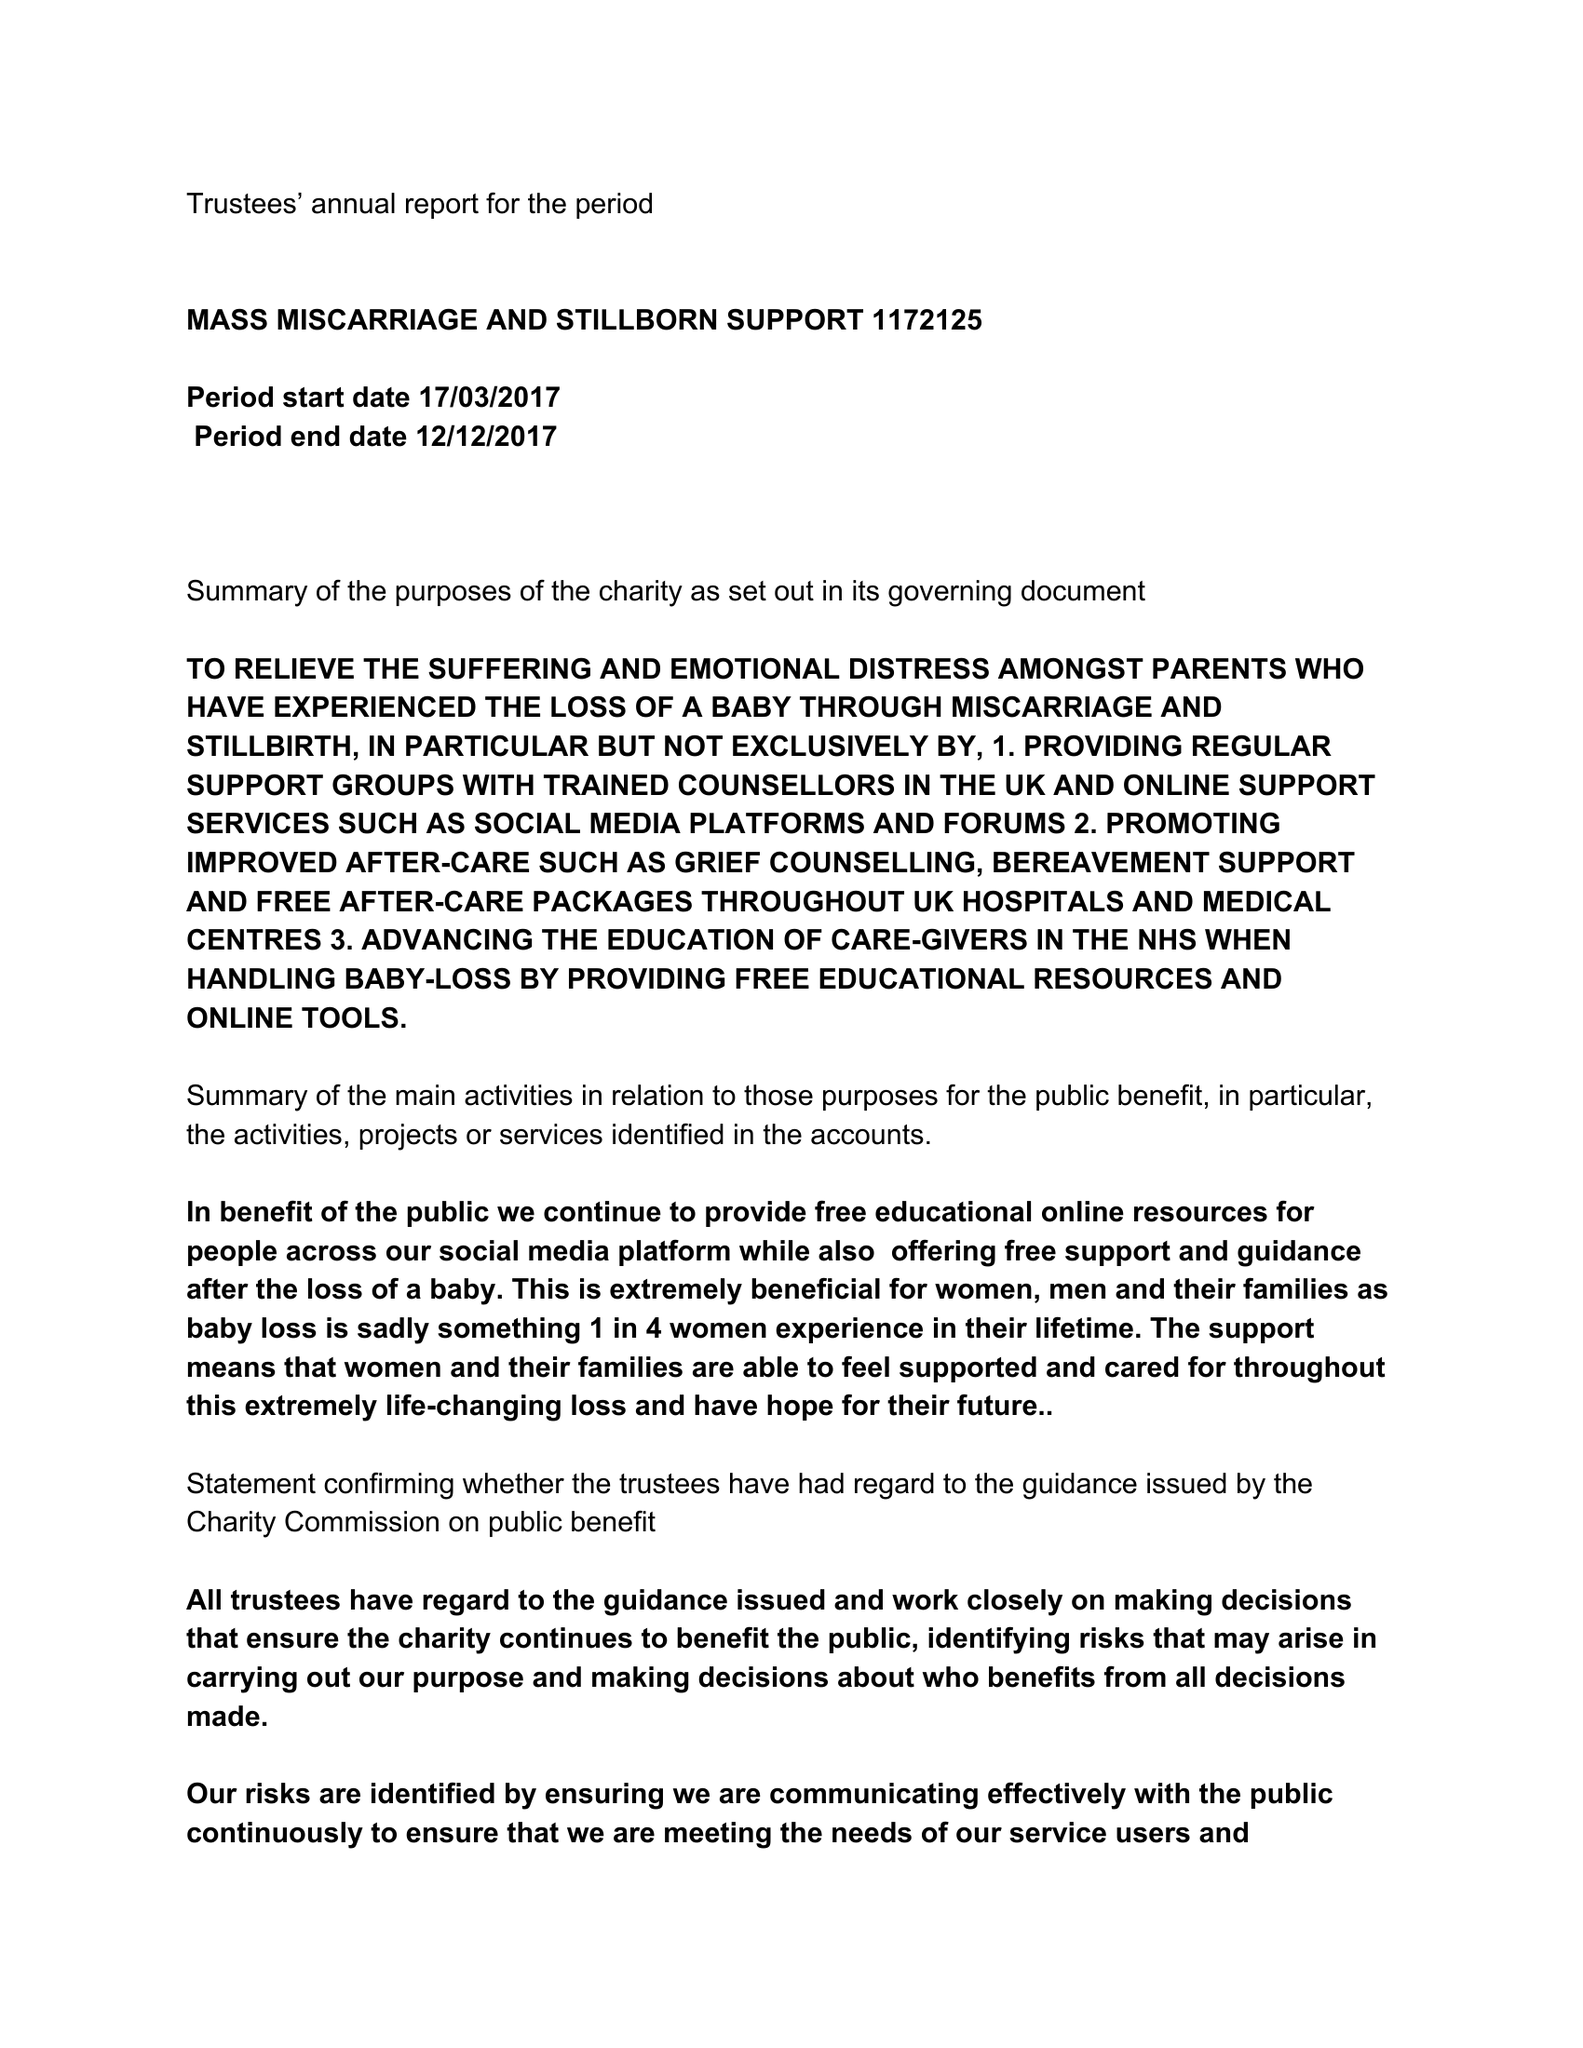What is the value for the address__post_town?
Answer the question using a single word or phrase. BEDFORD 